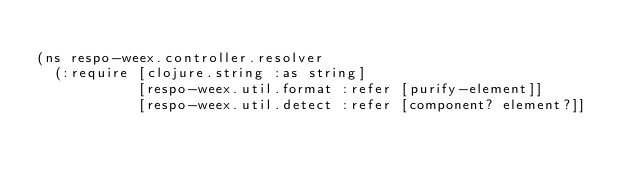<code> <loc_0><loc_0><loc_500><loc_500><_Clojure_>
(ns respo-weex.controller.resolver
  (:require [clojure.string :as string]
            [respo-weex.util.format :refer [purify-element]]
            [respo-weex.util.detect :refer [component? element?]]</code> 